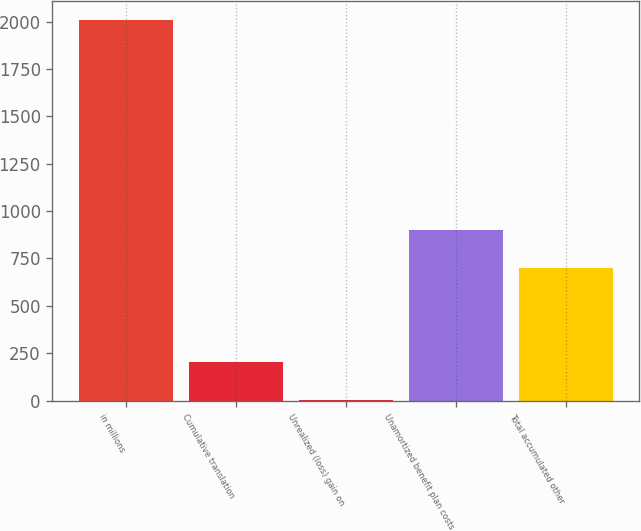<chart> <loc_0><loc_0><loc_500><loc_500><bar_chart><fcel>in millions<fcel>Cumulative translation<fcel>Unrealized (loss) gain on<fcel>Unamortized benefit plan costs<fcel>Total accumulated other<nl><fcel>2007<fcel>203.4<fcel>3<fcel>899.4<fcel>699<nl></chart> 